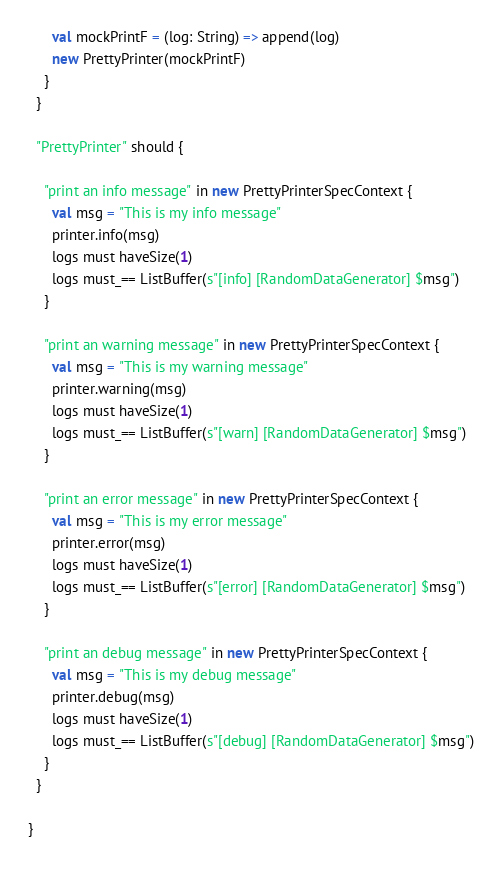<code> <loc_0><loc_0><loc_500><loc_500><_Scala_>      val mockPrintF = (log: String) => append(log)
      new PrettyPrinter(mockPrintF)
    }
  }

  "PrettyPrinter" should {

    "print an info message" in new PrettyPrinterSpecContext {
      val msg = "This is my info message"
      printer.info(msg)
      logs must haveSize(1)
      logs must_== ListBuffer(s"[info] [RandomDataGenerator] $msg")
    }

    "print an warning message" in new PrettyPrinterSpecContext {
      val msg = "This is my warning message"
      printer.warning(msg)
      logs must haveSize(1)
      logs must_== ListBuffer(s"[warn] [RandomDataGenerator] $msg")
    }

    "print an error message" in new PrettyPrinterSpecContext {
      val msg = "This is my error message"
      printer.error(msg)
      logs must haveSize(1)
      logs must_== ListBuffer(s"[error] [RandomDataGenerator] $msg")
    }

    "print an debug message" in new PrettyPrinterSpecContext {
      val msg = "This is my debug message"
      printer.debug(msg)
      logs must haveSize(1)
      logs must_== ListBuffer(s"[debug] [RandomDataGenerator] $msg")
    }
  }

}
</code> 